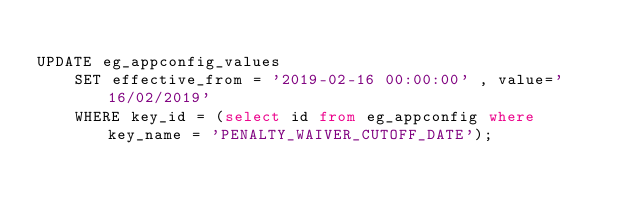<code> <loc_0><loc_0><loc_500><loc_500><_SQL_>
UPDATE eg_appconfig_values 
    SET effective_from = '2019-02-16 00:00:00' , value='16/02/2019'
    WHERE key_id = (select id from eg_appconfig where key_name = 'PENALTY_WAIVER_CUTOFF_DATE');
</code> 